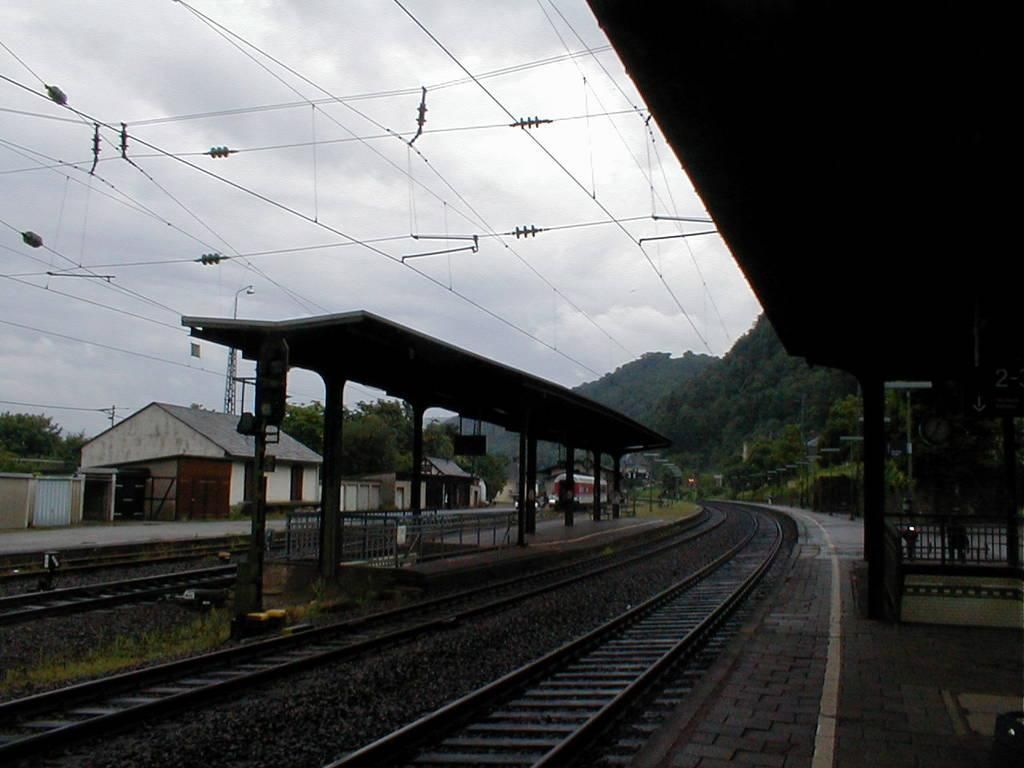What is the main subject of the image? The main subject of the image is a train. What can be seen alongside the train in the image? There is a train track, a platform, electric wires, trees, stones, and grass visible in the image. What is the condition of the sky in the image? The sky is cloudy in the image. Can you tell me how many elbows are visible in the image? There are no elbows present in the image. What type of twist can be seen in the train's movement in the image? The train is not moving in the image, so there is no twist in its movement. 